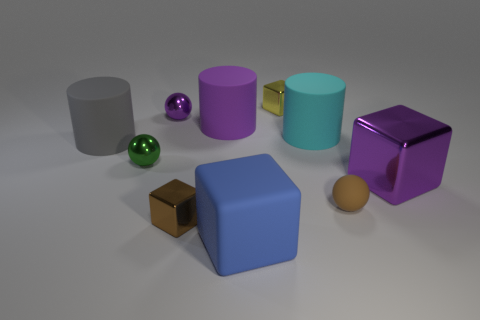Subtract 1 cubes. How many cubes are left? 3 Subtract all blue cubes. Subtract all green cylinders. How many cubes are left? 3 Subtract all blocks. How many objects are left? 6 Subtract 1 green spheres. How many objects are left? 9 Subtract all big cyan things. Subtract all gray cylinders. How many objects are left? 8 Add 3 tiny purple balls. How many tiny purple balls are left? 4 Add 9 tiny red metallic spheres. How many tiny red metallic spheres exist? 9 